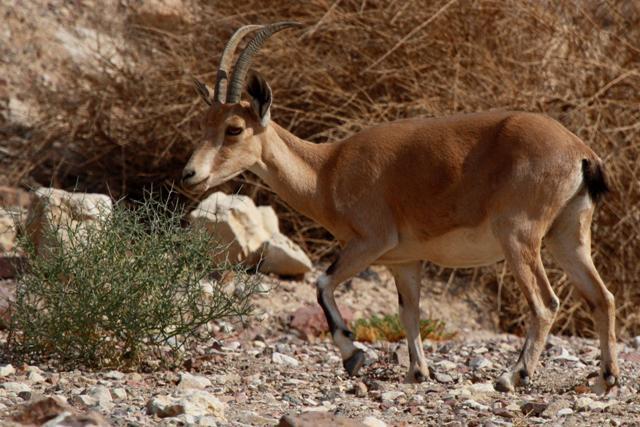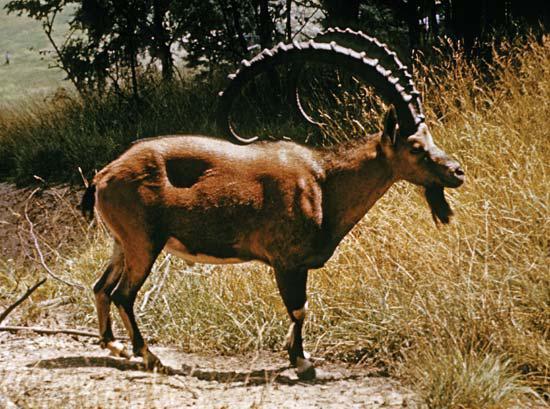The first image is the image on the left, the second image is the image on the right. For the images shown, is this caption "One of the paired images features exactly two animals." true? Answer yes or no. No. 